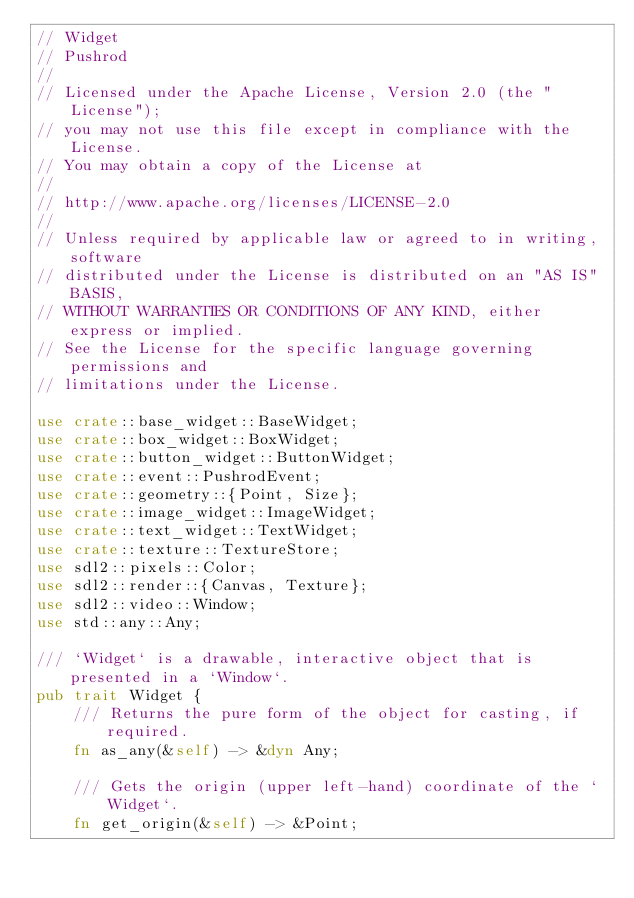Convert code to text. <code><loc_0><loc_0><loc_500><loc_500><_Rust_>// Widget
// Pushrod
//
// Licensed under the Apache License, Version 2.0 (the "License");
// you may not use this file except in compliance with the License.
// You may obtain a copy of the License at
//
// http://www.apache.org/licenses/LICENSE-2.0
//
// Unless required by applicable law or agreed to in writing, software
// distributed under the License is distributed on an "AS IS" BASIS,
// WITHOUT WARRANTIES OR CONDITIONS OF ANY KIND, either express or implied.
// See the License for the specific language governing permissions and
// limitations under the License.

use crate::base_widget::BaseWidget;
use crate::box_widget::BoxWidget;
use crate::button_widget::ButtonWidget;
use crate::event::PushrodEvent;
use crate::geometry::{Point, Size};
use crate::image_widget::ImageWidget;
use crate::text_widget::TextWidget;
use crate::texture::TextureStore;
use sdl2::pixels::Color;
use sdl2::render::{Canvas, Texture};
use sdl2::video::Window;
use std::any::Any;

/// `Widget` is a drawable, interactive object that is presented in a `Window`.
pub trait Widget {
    /// Returns the pure form of the object for casting, if required.
    fn as_any(&self) -> &dyn Any;

    /// Gets the origin (upper left-hand) coordinate of the `Widget`.
    fn get_origin(&self) -> &Point;
</code> 